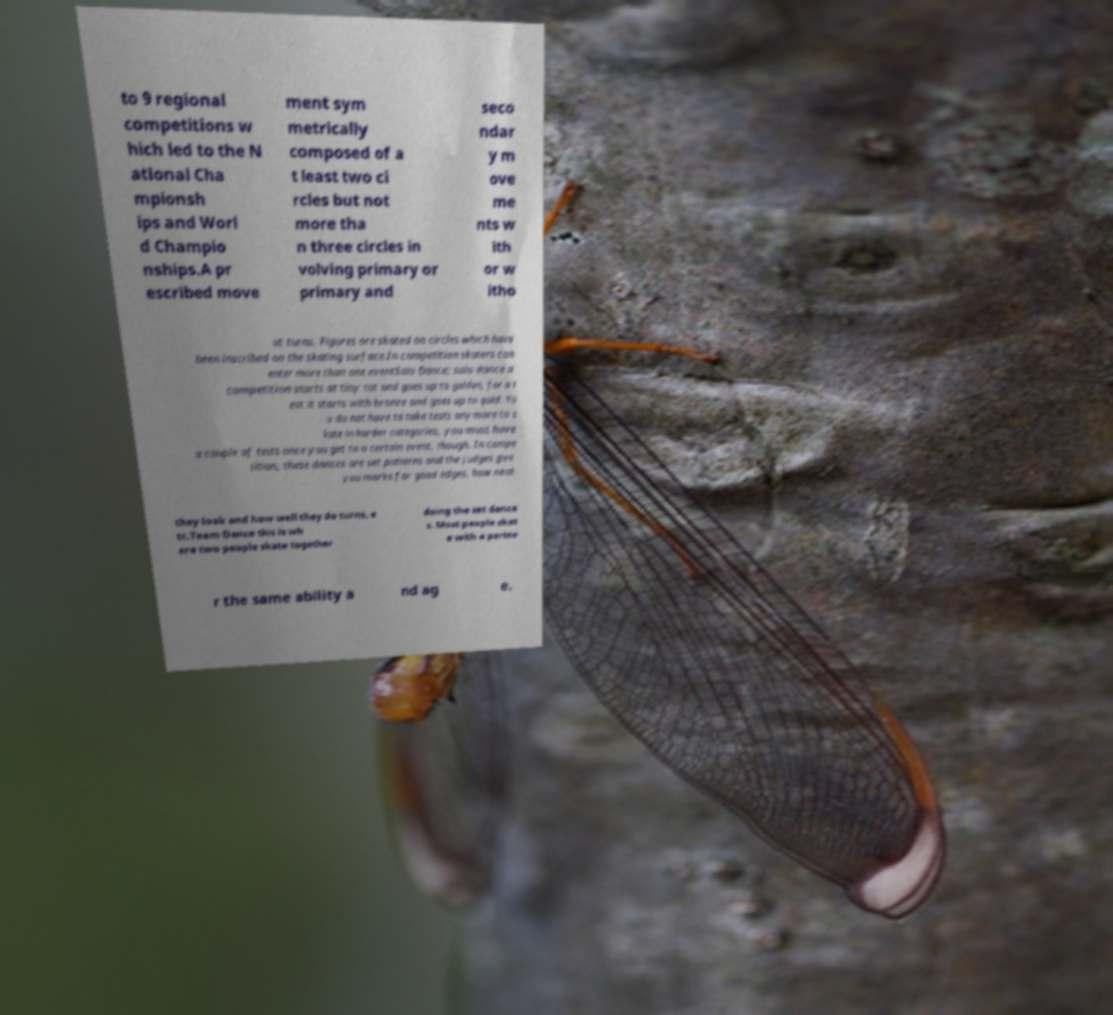Please identify and transcribe the text found in this image. to 9 regional competitions w hich led to the N ational Cha mpionsh ips and Worl d Champio nships.A pr escribed move ment sym metrically composed of a t least two ci rcles but not more tha n three circles in volving primary or primary and seco ndar y m ove me nts w ith or w itho ut turns. Figures are skated on circles which have been inscribed on the skating surface.In competition skaters can enter more than one eventSolo Dance; solo dance a competition starts at tiny tot and goes up to golden, for a t est it starts with bronze and goes up to gold. Yo u do not have to take tests anymore to s kate in harder categories, you must have a couple of tests once you get to a certain event, though. In compe tition, these dances are set patterns and the judges give you marks for good edges, how neat they look and how well they do turns, e tc.Team Dance this is wh ere two people skate together doing the set dance s. Most people skat e with a partne r the same ability a nd ag e. 